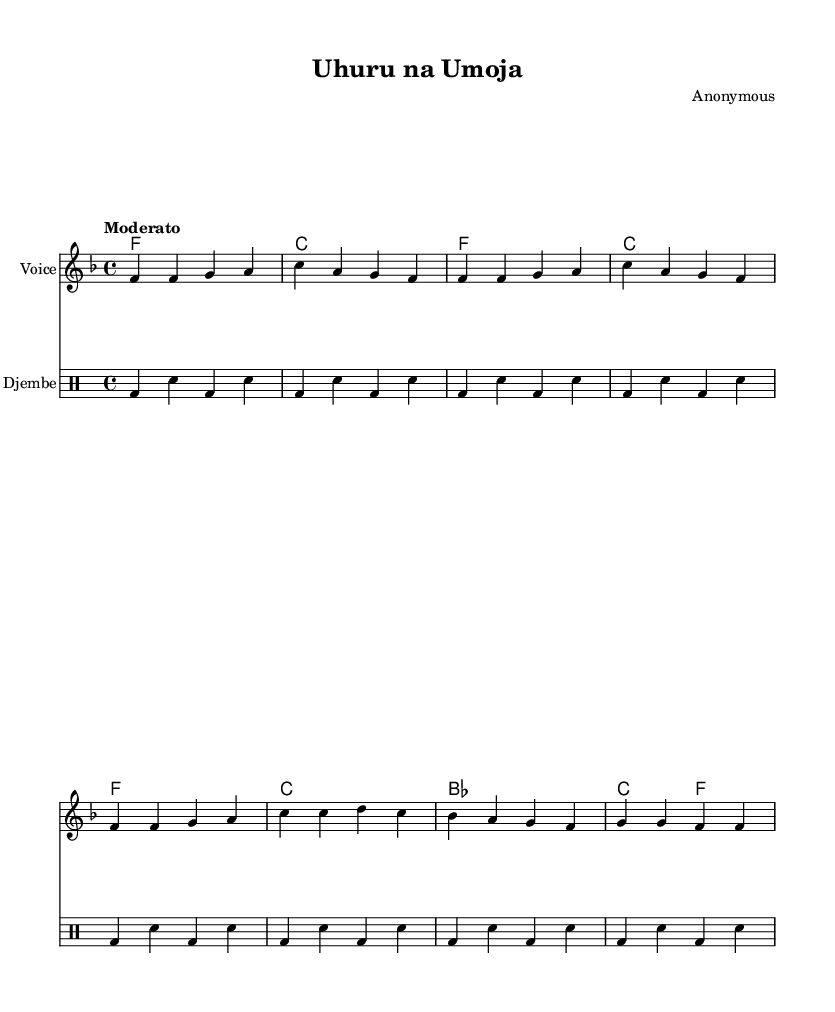What is the title of this music? The title is indicated in the header section of the sheet music. The header states "Uhuru na Umoja" as the title.
Answer: Uhuru na Umoja What is the key signature of this music? The sheet music has a key signature marked by the symbol right at the beginning. It shows one flat, which indicates the key of F major.
Answer: F major What is the time signature of this music? The time signature is represented by the numbers appearing after the key signature. Here, the time signature is shown as 4 over 4.
Answer: 4/4 What is the tempo marking in this music? The tempo is indicated within the score and is labeled as "Moderato," suggesting a moderate speed for the piece.
Answer: Moderato How many measures are present in the melody? By counting the measures in the melody section, we find a total of 8 measures based on the distinct grouping of notes.
Answer: 8 What is the instrument for which the melody is written? The instrument name is specified in the staff details in the score. The staff is labeled as "Voice," indicating that the melody is written for vocal performance.
Answer: Voice What type of drum is utilized in this piece? The sheet explicitly designates the drum staff as "Djembe," indicating that the rhythm section is played using this specific type of African drum.
Answer: Djembe 